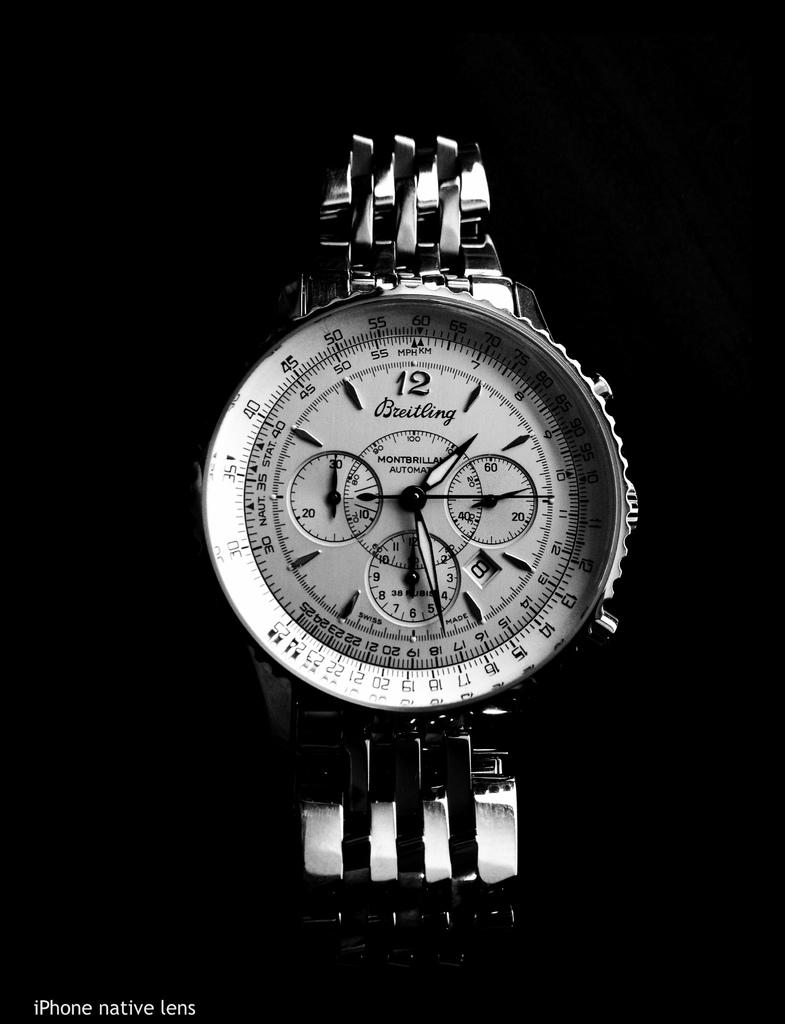What brand of watch is this?
Offer a very short reply. Breitling. 